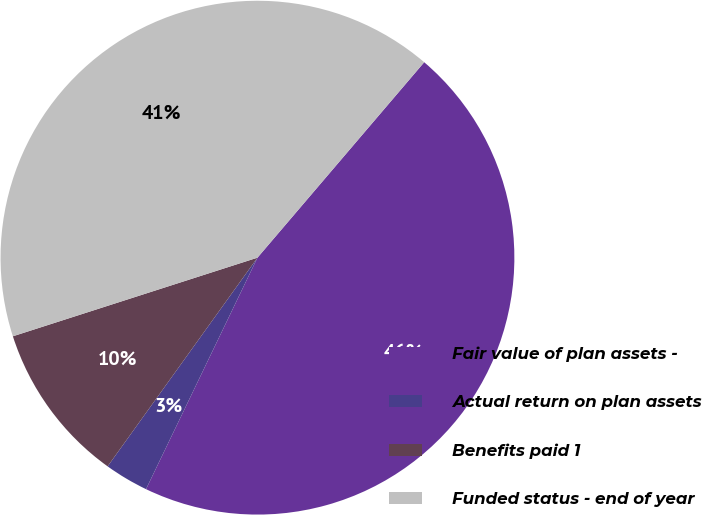Convert chart. <chart><loc_0><loc_0><loc_500><loc_500><pie_chart><fcel>Fair value of plan assets -<fcel>Actual return on plan assets<fcel>Benefits paid 1<fcel>Funded status - end of year<nl><fcel>45.9%<fcel>2.77%<fcel>10.14%<fcel>41.19%<nl></chart> 